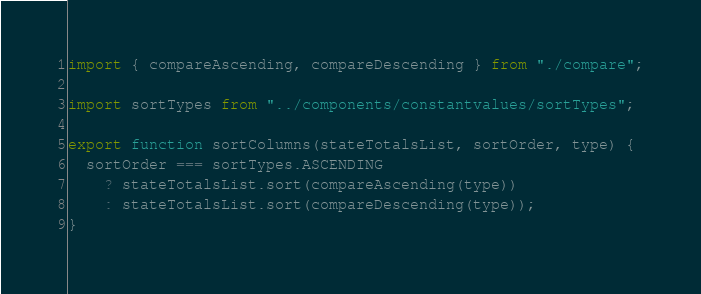Convert code to text. <code><loc_0><loc_0><loc_500><loc_500><_JavaScript_>import { compareAscending, compareDescending } from "./compare";

import sortTypes from "../components/constantvalues/sortTypes";

export function sortColumns(stateTotalsList, sortOrder, type) {
  sortOrder === sortTypes.ASCENDING
    ? stateTotalsList.sort(compareAscending(type))
    : stateTotalsList.sort(compareDescending(type));
}
</code> 